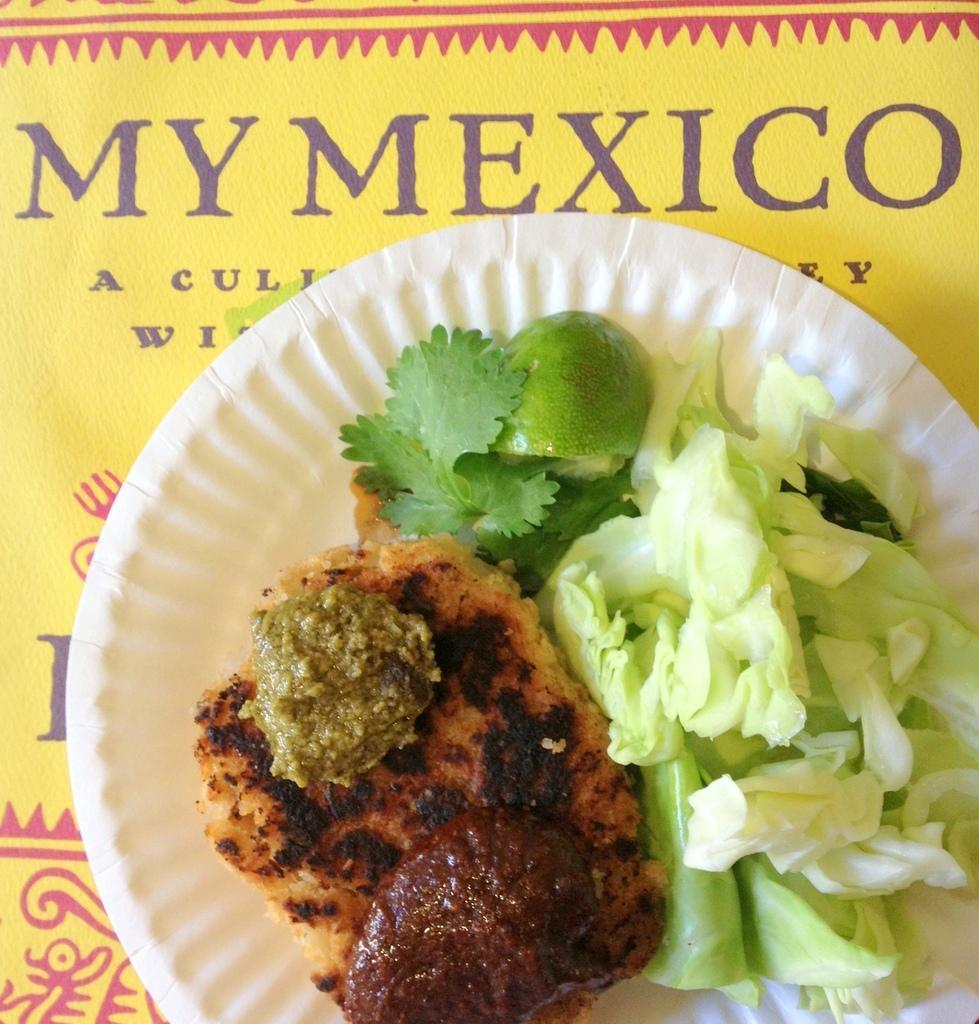Please provide a concise description of this image. In this image we can see food in a paper plate which is on a yellow color platform and we can see text written on it. 